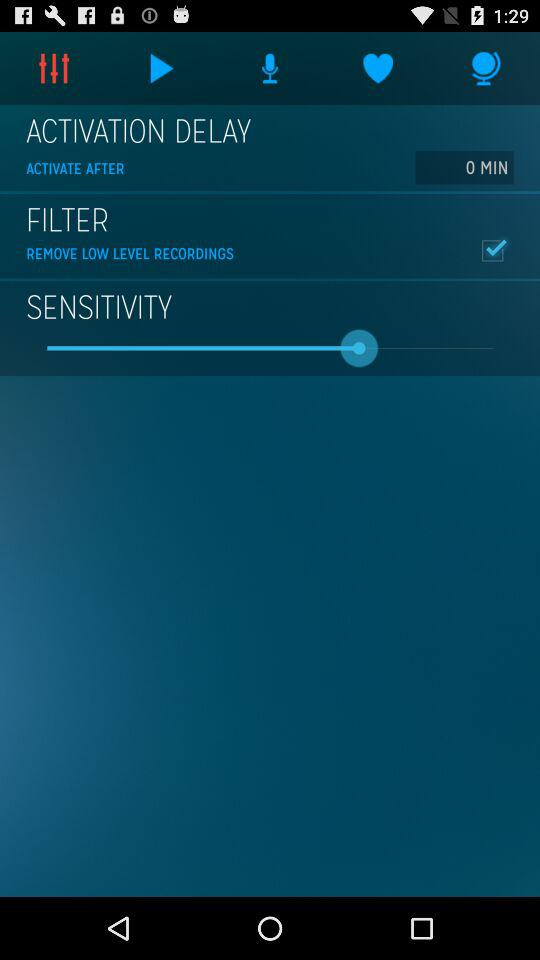How many recordings are there?
When the provided information is insufficient, respond with <no answer>. <no answer> 